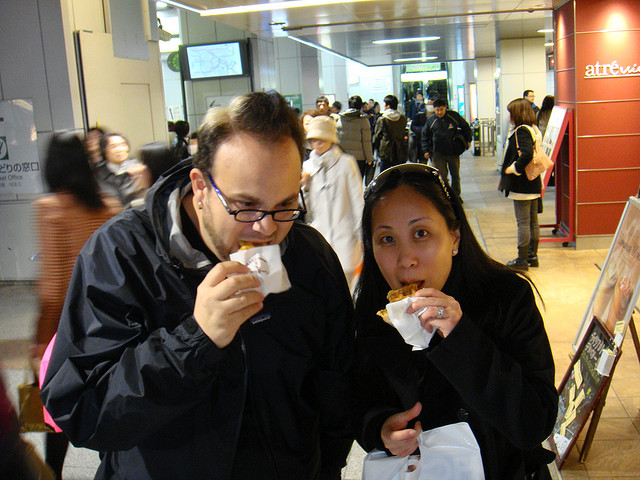<image>What number is on the sign? I don't know what number is on the sign. It could be '1', '2', '6', '7', '72' or '0'. What number is on the sign? I don't know what number is on the sign. It can be either '6', '72', '1', '0', '2', '7' or 'no number'. 